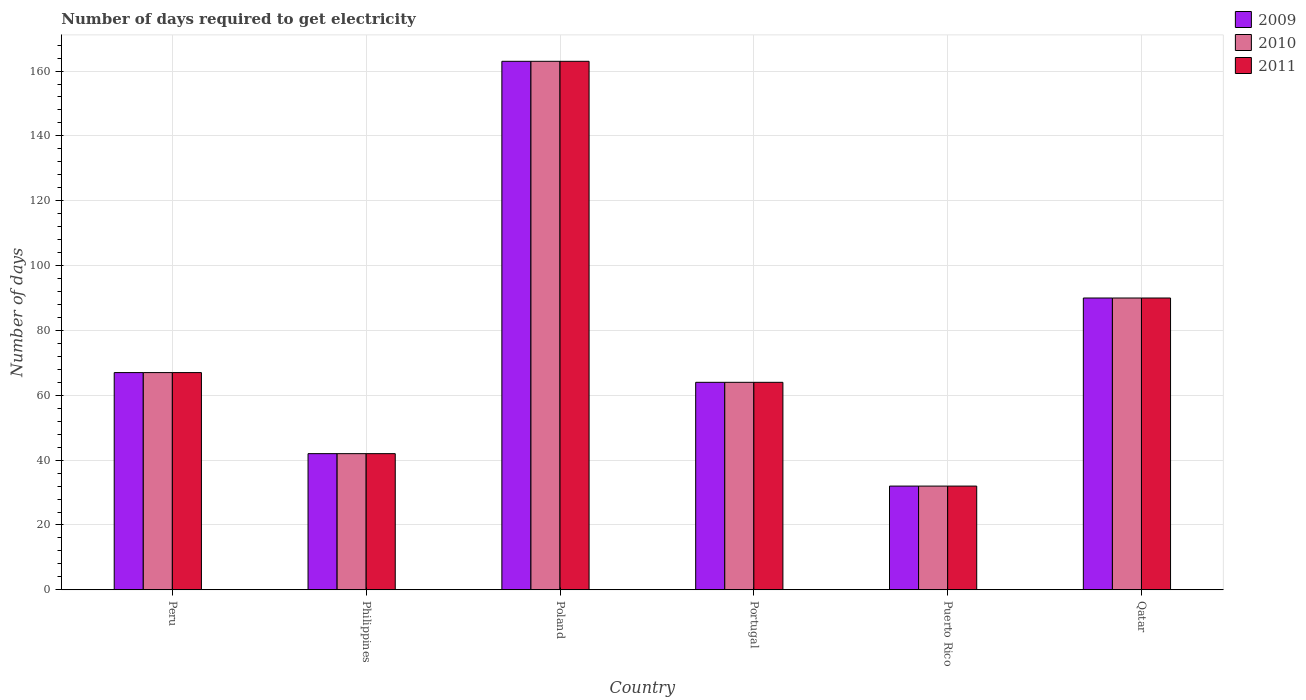How many different coloured bars are there?
Provide a succinct answer. 3. Are the number of bars per tick equal to the number of legend labels?
Your response must be concise. Yes. In how many cases, is the number of bars for a given country not equal to the number of legend labels?
Provide a short and direct response. 0. Across all countries, what is the maximum number of days required to get electricity in in 2009?
Ensure brevity in your answer.  163. In which country was the number of days required to get electricity in in 2009 maximum?
Keep it short and to the point. Poland. In which country was the number of days required to get electricity in in 2010 minimum?
Your answer should be very brief. Puerto Rico. What is the total number of days required to get electricity in in 2010 in the graph?
Keep it short and to the point. 458. What is the average number of days required to get electricity in in 2009 per country?
Your answer should be very brief. 76.33. In how many countries, is the number of days required to get electricity in in 2010 greater than 72 days?
Your answer should be compact. 2. What is the ratio of the number of days required to get electricity in in 2009 in Peru to that in Philippines?
Make the answer very short. 1.6. Is the number of days required to get electricity in in 2011 in Philippines less than that in Puerto Rico?
Offer a terse response. No. Is the difference between the number of days required to get electricity in in 2010 in Philippines and Qatar greater than the difference between the number of days required to get electricity in in 2011 in Philippines and Qatar?
Offer a very short reply. No. What is the difference between the highest and the second highest number of days required to get electricity in in 2010?
Make the answer very short. -23. What is the difference between the highest and the lowest number of days required to get electricity in in 2010?
Provide a short and direct response. 131. In how many countries, is the number of days required to get electricity in in 2010 greater than the average number of days required to get electricity in in 2010 taken over all countries?
Provide a short and direct response. 2. Is the sum of the number of days required to get electricity in in 2011 in Poland and Qatar greater than the maximum number of days required to get electricity in in 2010 across all countries?
Offer a terse response. Yes. Is it the case that in every country, the sum of the number of days required to get electricity in in 2011 and number of days required to get electricity in in 2010 is greater than the number of days required to get electricity in in 2009?
Give a very brief answer. Yes. How many countries are there in the graph?
Your response must be concise. 6. What is the difference between two consecutive major ticks on the Y-axis?
Provide a short and direct response. 20. Are the values on the major ticks of Y-axis written in scientific E-notation?
Offer a terse response. No. Does the graph contain grids?
Ensure brevity in your answer.  Yes. Where does the legend appear in the graph?
Your response must be concise. Top right. How are the legend labels stacked?
Offer a very short reply. Vertical. What is the title of the graph?
Your answer should be compact. Number of days required to get electricity. What is the label or title of the X-axis?
Your response must be concise. Country. What is the label or title of the Y-axis?
Your answer should be very brief. Number of days. What is the Number of days of 2009 in Peru?
Your answer should be very brief. 67. What is the Number of days in 2010 in Peru?
Provide a succinct answer. 67. What is the Number of days in 2011 in Peru?
Your answer should be compact. 67. What is the Number of days of 2009 in Philippines?
Offer a terse response. 42. What is the Number of days of 2009 in Poland?
Offer a terse response. 163. What is the Number of days in 2010 in Poland?
Your answer should be compact. 163. What is the Number of days in 2011 in Poland?
Your response must be concise. 163. What is the Number of days of 2009 in Portugal?
Offer a terse response. 64. What is the Number of days in 2011 in Portugal?
Offer a very short reply. 64. What is the Number of days in 2010 in Qatar?
Your answer should be compact. 90. Across all countries, what is the maximum Number of days in 2009?
Your answer should be compact. 163. Across all countries, what is the maximum Number of days in 2010?
Your answer should be compact. 163. Across all countries, what is the maximum Number of days in 2011?
Offer a very short reply. 163. Across all countries, what is the minimum Number of days of 2010?
Your answer should be compact. 32. Across all countries, what is the minimum Number of days in 2011?
Your response must be concise. 32. What is the total Number of days of 2009 in the graph?
Make the answer very short. 458. What is the total Number of days of 2010 in the graph?
Ensure brevity in your answer.  458. What is the total Number of days in 2011 in the graph?
Offer a very short reply. 458. What is the difference between the Number of days of 2009 in Peru and that in Philippines?
Provide a succinct answer. 25. What is the difference between the Number of days of 2010 in Peru and that in Philippines?
Offer a very short reply. 25. What is the difference between the Number of days in 2011 in Peru and that in Philippines?
Ensure brevity in your answer.  25. What is the difference between the Number of days in 2009 in Peru and that in Poland?
Your answer should be very brief. -96. What is the difference between the Number of days of 2010 in Peru and that in Poland?
Your answer should be compact. -96. What is the difference between the Number of days of 2011 in Peru and that in Poland?
Ensure brevity in your answer.  -96. What is the difference between the Number of days in 2010 in Peru and that in Portugal?
Your answer should be compact. 3. What is the difference between the Number of days in 2010 in Peru and that in Puerto Rico?
Your answer should be very brief. 35. What is the difference between the Number of days in 2011 in Peru and that in Puerto Rico?
Your response must be concise. 35. What is the difference between the Number of days of 2010 in Peru and that in Qatar?
Keep it short and to the point. -23. What is the difference between the Number of days in 2009 in Philippines and that in Poland?
Your answer should be very brief. -121. What is the difference between the Number of days in 2010 in Philippines and that in Poland?
Your answer should be very brief. -121. What is the difference between the Number of days in 2011 in Philippines and that in Poland?
Your answer should be very brief. -121. What is the difference between the Number of days in 2009 in Philippines and that in Portugal?
Your answer should be very brief. -22. What is the difference between the Number of days in 2011 in Philippines and that in Portugal?
Keep it short and to the point. -22. What is the difference between the Number of days of 2009 in Philippines and that in Qatar?
Offer a terse response. -48. What is the difference between the Number of days of 2010 in Philippines and that in Qatar?
Offer a very short reply. -48. What is the difference between the Number of days of 2011 in Philippines and that in Qatar?
Provide a short and direct response. -48. What is the difference between the Number of days of 2010 in Poland and that in Portugal?
Give a very brief answer. 99. What is the difference between the Number of days in 2009 in Poland and that in Puerto Rico?
Keep it short and to the point. 131. What is the difference between the Number of days of 2010 in Poland and that in Puerto Rico?
Give a very brief answer. 131. What is the difference between the Number of days of 2011 in Poland and that in Puerto Rico?
Your response must be concise. 131. What is the difference between the Number of days in 2009 in Poland and that in Qatar?
Your response must be concise. 73. What is the difference between the Number of days in 2010 in Poland and that in Qatar?
Ensure brevity in your answer.  73. What is the difference between the Number of days of 2009 in Portugal and that in Puerto Rico?
Ensure brevity in your answer.  32. What is the difference between the Number of days in 2010 in Portugal and that in Puerto Rico?
Provide a succinct answer. 32. What is the difference between the Number of days of 2011 in Portugal and that in Puerto Rico?
Give a very brief answer. 32. What is the difference between the Number of days of 2009 in Portugal and that in Qatar?
Your response must be concise. -26. What is the difference between the Number of days of 2010 in Portugal and that in Qatar?
Offer a terse response. -26. What is the difference between the Number of days of 2011 in Portugal and that in Qatar?
Keep it short and to the point. -26. What is the difference between the Number of days in 2009 in Puerto Rico and that in Qatar?
Your answer should be compact. -58. What is the difference between the Number of days of 2010 in Puerto Rico and that in Qatar?
Offer a terse response. -58. What is the difference between the Number of days in 2011 in Puerto Rico and that in Qatar?
Offer a terse response. -58. What is the difference between the Number of days in 2009 in Peru and the Number of days in 2011 in Philippines?
Keep it short and to the point. 25. What is the difference between the Number of days in 2010 in Peru and the Number of days in 2011 in Philippines?
Provide a short and direct response. 25. What is the difference between the Number of days in 2009 in Peru and the Number of days in 2010 in Poland?
Your answer should be compact. -96. What is the difference between the Number of days in 2009 in Peru and the Number of days in 2011 in Poland?
Provide a short and direct response. -96. What is the difference between the Number of days of 2010 in Peru and the Number of days of 2011 in Poland?
Your answer should be compact. -96. What is the difference between the Number of days in 2009 in Peru and the Number of days in 2010 in Portugal?
Give a very brief answer. 3. What is the difference between the Number of days of 2010 in Peru and the Number of days of 2011 in Portugal?
Ensure brevity in your answer.  3. What is the difference between the Number of days in 2009 in Peru and the Number of days in 2010 in Puerto Rico?
Provide a short and direct response. 35. What is the difference between the Number of days in 2010 in Peru and the Number of days in 2011 in Puerto Rico?
Offer a terse response. 35. What is the difference between the Number of days in 2009 in Philippines and the Number of days in 2010 in Poland?
Offer a very short reply. -121. What is the difference between the Number of days in 2009 in Philippines and the Number of days in 2011 in Poland?
Your response must be concise. -121. What is the difference between the Number of days of 2010 in Philippines and the Number of days of 2011 in Poland?
Make the answer very short. -121. What is the difference between the Number of days of 2009 in Philippines and the Number of days of 2010 in Portugal?
Provide a succinct answer. -22. What is the difference between the Number of days of 2009 in Philippines and the Number of days of 2011 in Portugal?
Your answer should be compact. -22. What is the difference between the Number of days in 2009 in Philippines and the Number of days in 2010 in Puerto Rico?
Ensure brevity in your answer.  10. What is the difference between the Number of days in 2010 in Philippines and the Number of days in 2011 in Puerto Rico?
Keep it short and to the point. 10. What is the difference between the Number of days in 2009 in Philippines and the Number of days in 2010 in Qatar?
Give a very brief answer. -48. What is the difference between the Number of days in 2009 in Philippines and the Number of days in 2011 in Qatar?
Give a very brief answer. -48. What is the difference between the Number of days of 2010 in Philippines and the Number of days of 2011 in Qatar?
Offer a very short reply. -48. What is the difference between the Number of days of 2009 in Poland and the Number of days of 2011 in Portugal?
Your answer should be very brief. 99. What is the difference between the Number of days of 2009 in Poland and the Number of days of 2010 in Puerto Rico?
Your response must be concise. 131. What is the difference between the Number of days in 2009 in Poland and the Number of days in 2011 in Puerto Rico?
Your response must be concise. 131. What is the difference between the Number of days of 2010 in Poland and the Number of days of 2011 in Puerto Rico?
Your answer should be compact. 131. What is the difference between the Number of days of 2009 in Poland and the Number of days of 2010 in Qatar?
Your answer should be very brief. 73. What is the difference between the Number of days of 2009 in Poland and the Number of days of 2011 in Qatar?
Provide a succinct answer. 73. What is the difference between the Number of days in 2010 in Poland and the Number of days in 2011 in Qatar?
Make the answer very short. 73. What is the difference between the Number of days of 2009 in Portugal and the Number of days of 2010 in Puerto Rico?
Offer a very short reply. 32. What is the difference between the Number of days of 2009 in Portugal and the Number of days of 2011 in Puerto Rico?
Your answer should be compact. 32. What is the difference between the Number of days of 2010 in Portugal and the Number of days of 2011 in Puerto Rico?
Keep it short and to the point. 32. What is the difference between the Number of days in 2009 in Portugal and the Number of days in 2010 in Qatar?
Make the answer very short. -26. What is the difference between the Number of days of 2009 in Portugal and the Number of days of 2011 in Qatar?
Your answer should be compact. -26. What is the difference between the Number of days of 2010 in Portugal and the Number of days of 2011 in Qatar?
Make the answer very short. -26. What is the difference between the Number of days of 2009 in Puerto Rico and the Number of days of 2010 in Qatar?
Make the answer very short. -58. What is the difference between the Number of days in 2009 in Puerto Rico and the Number of days in 2011 in Qatar?
Keep it short and to the point. -58. What is the difference between the Number of days in 2010 in Puerto Rico and the Number of days in 2011 in Qatar?
Your answer should be very brief. -58. What is the average Number of days in 2009 per country?
Your response must be concise. 76.33. What is the average Number of days in 2010 per country?
Ensure brevity in your answer.  76.33. What is the average Number of days in 2011 per country?
Provide a succinct answer. 76.33. What is the difference between the Number of days in 2009 and Number of days in 2010 in Peru?
Keep it short and to the point. 0. What is the difference between the Number of days of 2010 and Number of days of 2011 in Peru?
Make the answer very short. 0. What is the difference between the Number of days in 2009 and Number of days in 2010 in Philippines?
Give a very brief answer. 0. What is the difference between the Number of days of 2009 and Number of days of 2011 in Philippines?
Keep it short and to the point. 0. What is the difference between the Number of days in 2009 and Number of days in 2011 in Poland?
Your response must be concise. 0. What is the difference between the Number of days in 2010 and Number of days in 2011 in Poland?
Make the answer very short. 0. What is the difference between the Number of days in 2009 and Number of days in 2010 in Portugal?
Make the answer very short. 0. What is the difference between the Number of days of 2009 and Number of days of 2011 in Portugal?
Your answer should be compact. 0. What is the difference between the Number of days in 2010 and Number of days in 2011 in Puerto Rico?
Your answer should be compact. 0. What is the difference between the Number of days in 2009 and Number of days in 2011 in Qatar?
Provide a succinct answer. 0. What is the difference between the Number of days in 2010 and Number of days in 2011 in Qatar?
Offer a very short reply. 0. What is the ratio of the Number of days in 2009 in Peru to that in Philippines?
Keep it short and to the point. 1.6. What is the ratio of the Number of days of 2010 in Peru to that in Philippines?
Provide a succinct answer. 1.6. What is the ratio of the Number of days of 2011 in Peru to that in Philippines?
Your response must be concise. 1.6. What is the ratio of the Number of days in 2009 in Peru to that in Poland?
Give a very brief answer. 0.41. What is the ratio of the Number of days in 2010 in Peru to that in Poland?
Provide a succinct answer. 0.41. What is the ratio of the Number of days of 2011 in Peru to that in Poland?
Give a very brief answer. 0.41. What is the ratio of the Number of days of 2009 in Peru to that in Portugal?
Offer a very short reply. 1.05. What is the ratio of the Number of days in 2010 in Peru to that in Portugal?
Offer a terse response. 1.05. What is the ratio of the Number of days of 2011 in Peru to that in Portugal?
Your answer should be compact. 1.05. What is the ratio of the Number of days in 2009 in Peru to that in Puerto Rico?
Keep it short and to the point. 2.09. What is the ratio of the Number of days in 2010 in Peru to that in Puerto Rico?
Your answer should be compact. 2.09. What is the ratio of the Number of days of 2011 in Peru to that in Puerto Rico?
Keep it short and to the point. 2.09. What is the ratio of the Number of days of 2009 in Peru to that in Qatar?
Provide a short and direct response. 0.74. What is the ratio of the Number of days in 2010 in Peru to that in Qatar?
Offer a very short reply. 0.74. What is the ratio of the Number of days in 2011 in Peru to that in Qatar?
Offer a very short reply. 0.74. What is the ratio of the Number of days of 2009 in Philippines to that in Poland?
Make the answer very short. 0.26. What is the ratio of the Number of days in 2010 in Philippines to that in Poland?
Offer a terse response. 0.26. What is the ratio of the Number of days of 2011 in Philippines to that in Poland?
Offer a terse response. 0.26. What is the ratio of the Number of days of 2009 in Philippines to that in Portugal?
Provide a short and direct response. 0.66. What is the ratio of the Number of days of 2010 in Philippines to that in Portugal?
Offer a very short reply. 0.66. What is the ratio of the Number of days of 2011 in Philippines to that in Portugal?
Your answer should be very brief. 0.66. What is the ratio of the Number of days in 2009 in Philippines to that in Puerto Rico?
Provide a short and direct response. 1.31. What is the ratio of the Number of days in 2010 in Philippines to that in Puerto Rico?
Offer a terse response. 1.31. What is the ratio of the Number of days in 2011 in Philippines to that in Puerto Rico?
Your answer should be very brief. 1.31. What is the ratio of the Number of days in 2009 in Philippines to that in Qatar?
Your answer should be very brief. 0.47. What is the ratio of the Number of days in 2010 in Philippines to that in Qatar?
Give a very brief answer. 0.47. What is the ratio of the Number of days of 2011 in Philippines to that in Qatar?
Provide a short and direct response. 0.47. What is the ratio of the Number of days of 2009 in Poland to that in Portugal?
Provide a short and direct response. 2.55. What is the ratio of the Number of days of 2010 in Poland to that in Portugal?
Your answer should be compact. 2.55. What is the ratio of the Number of days of 2011 in Poland to that in Portugal?
Provide a succinct answer. 2.55. What is the ratio of the Number of days in 2009 in Poland to that in Puerto Rico?
Your answer should be very brief. 5.09. What is the ratio of the Number of days of 2010 in Poland to that in Puerto Rico?
Keep it short and to the point. 5.09. What is the ratio of the Number of days of 2011 in Poland to that in Puerto Rico?
Offer a terse response. 5.09. What is the ratio of the Number of days of 2009 in Poland to that in Qatar?
Give a very brief answer. 1.81. What is the ratio of the Number of days in 2010 in Poland to that in Qatar?
Provide a short and direct response. 1.81. What is the ratio of the Number of days in 2011 in Poland to that in Qatar?
Offer a terse response. 1.81. What is the ratio of the Number of days of 2010 in Portugal to that in Puerto Rico?
Your response must be concise. 2. What is the ratio of the Number of days in 2009 in Portugal to that in Qatar?
Your answer should be very brief. 0.71. What is the ratio of the Number of days in 2010 in Portugal to that in Qatar?
Offer a very short reply. 0.71. What is the ratio of the Number of days in 2011 in Portugal to that in Qatar?
Offer a very short reply. 0.71. What is the ratio of the Number of days of 2009 in Puerto Rico to that in Qatar?
Provide a succinct answer. 0.36. What is the ratio of the Number of days of 2010 in Puerto Rico to that in Qatar?
Offer a very short reply. 0.36. What is the ratio of the Number of days of 2011 in Puerto Rico to that in Qatar?
Keep it short and to the point. 0.36. What is the difference between the highest and the second highest Number of days of 2010?
Your answer should be very brief. 73. What is the difference between the highest and the lowest Number of days in 2009?
Provide a short and direct response. 131. What is the difference between the highest and the lowest Number of days of 2010?
Keep it short and to the point. 131. What is the difference between the highest and the lowest Number of days in 2011?
Keep it short and to the point. 131. 